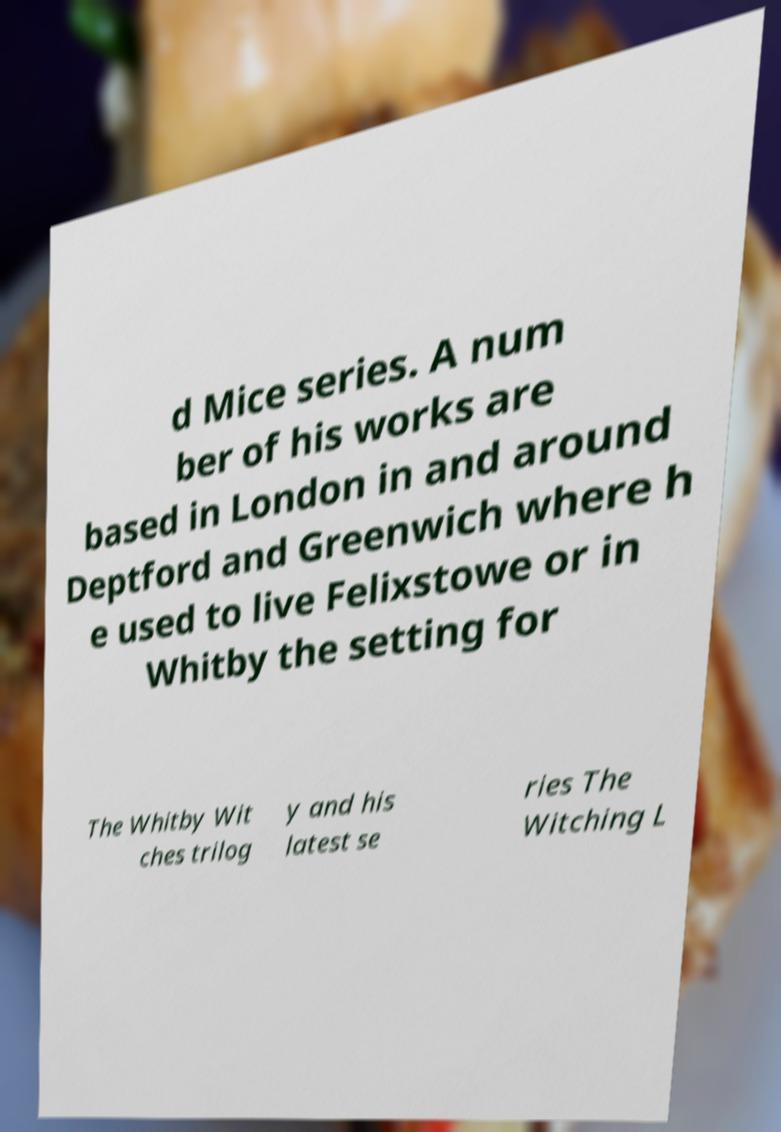I need the written content from this picture converted into text. Can you do that? d Mice series. A num ber of his works are based in London in and around Deptford and Greenwich where h e used to live Felixstowe or in Whitby the setting for The Whitby Wit ches trilog y and his latest se ries The Witching L 